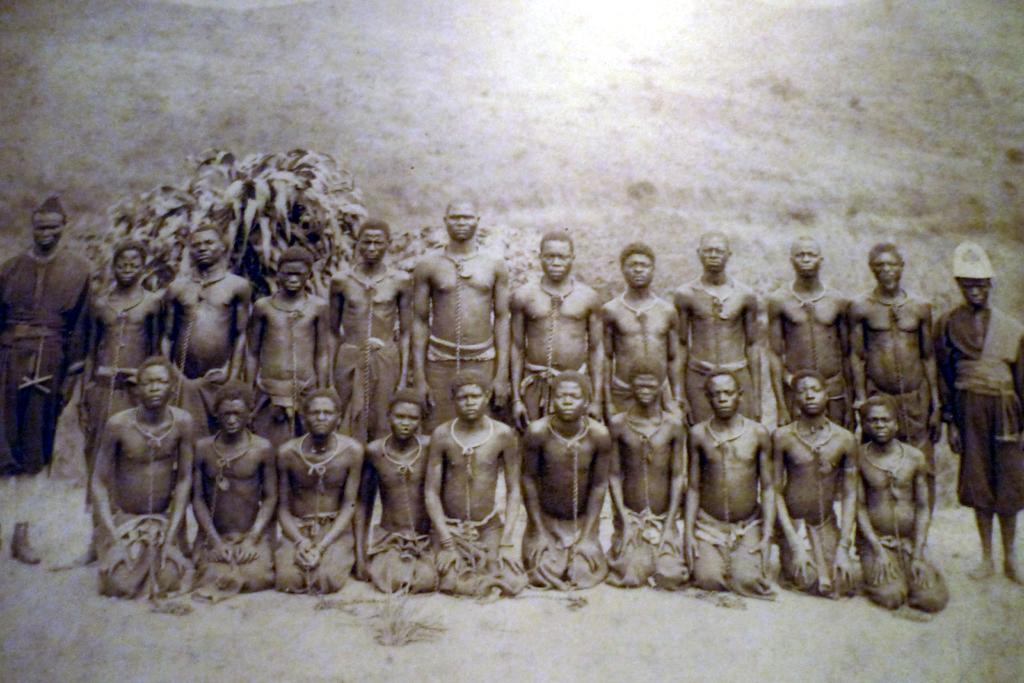In one or two sentences, can you explain what this image depicts? In this image there are few persons standing on the land. Left side there is a plant. Right side there is a person standing and he is wearing a cap. Few persons are kneeling down on the land. 